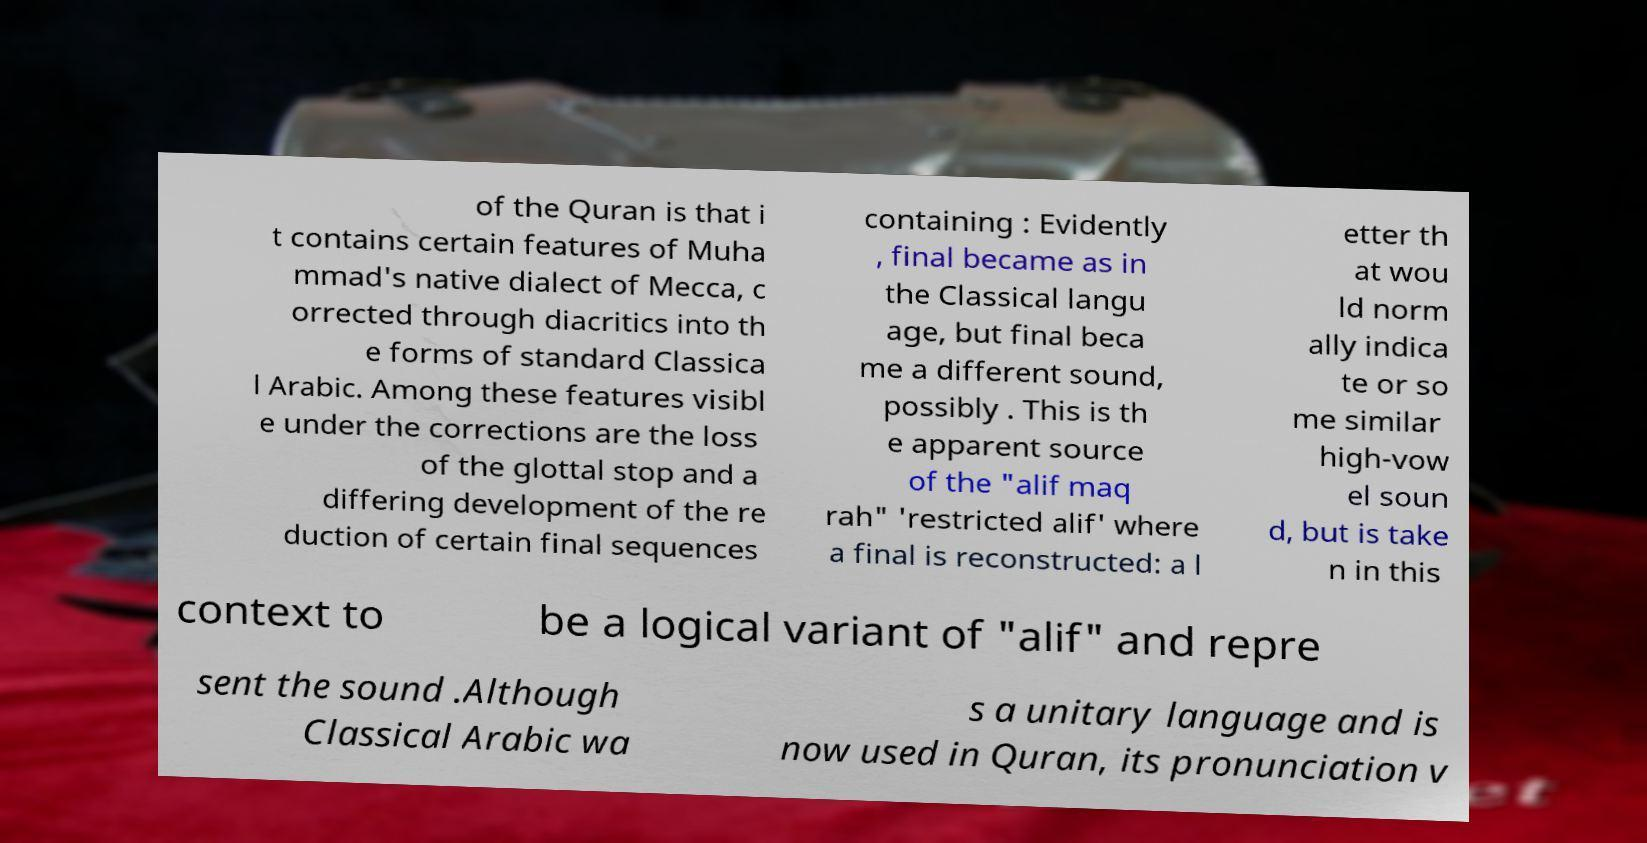Please read and relay the text visible in this image. What does it say? of the Quran is that i t contains certain features of Muha mmad's native dialect of Mecca, c orrected through diacritics into th e forms of standard Classica l Arabic. Among these features visibl e under the corrections are the loss of the glottal stop and a differing development of the re duction of certain final sequences containing : Evidently , final became as in the Classical langu age, but final beca me a different sound, possibly . This is th e apparent source of the "alif maq rah" 'restricted alif' where a final is reconstructed: a l etter th at wou ld norm ally indica te or so me similar high-vow el soun d, but is take n in this context to be a logical variant of "alif" and repre sent the sound .Although Classical Arabic wa s a unitary language and is now used in Quran, its pronunciation v 